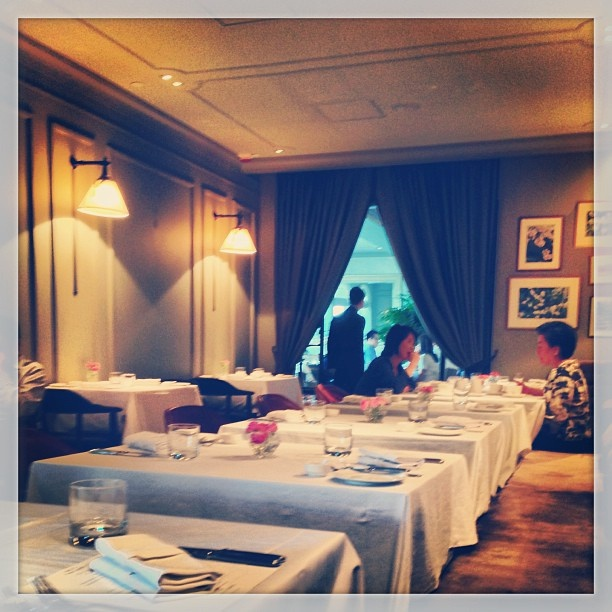Describe the objects in this image and their specific colors. I can see dining table in lightgray, gray, tan, and darkgray tones, dining table in lightgray, tan, darkgray, and gray tones, dining table in lightgray and tan tones, people in lightgray, navy, brown, black, and tan tones, and dining table in lightgray, salmon, and tan tones in this image. 